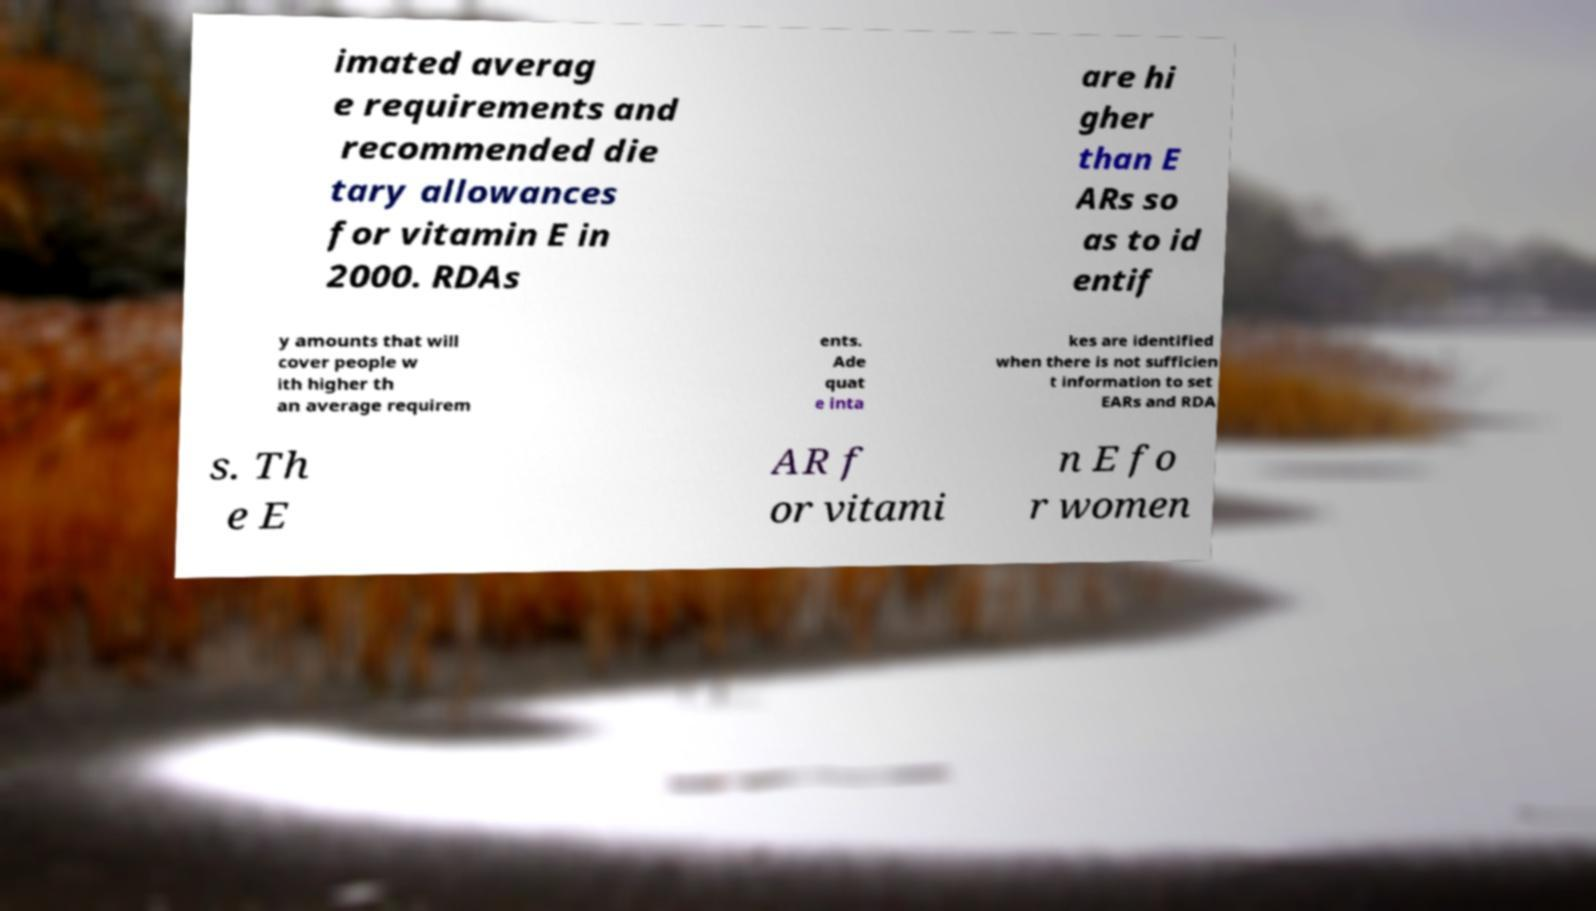Please identify and transcribe the text found in this image. imated averag e requirements and recommended die tary allowances for vitamin E in 2000. RDAs are hi gher than E ARs so as to id entif y amounts that will cover people w ith higher th an average requirem ents. Ade quat e inta kes are identified when there is not sufficien t information to set EARs and RDA s. Th e E AR f or vitami n E fo r women 